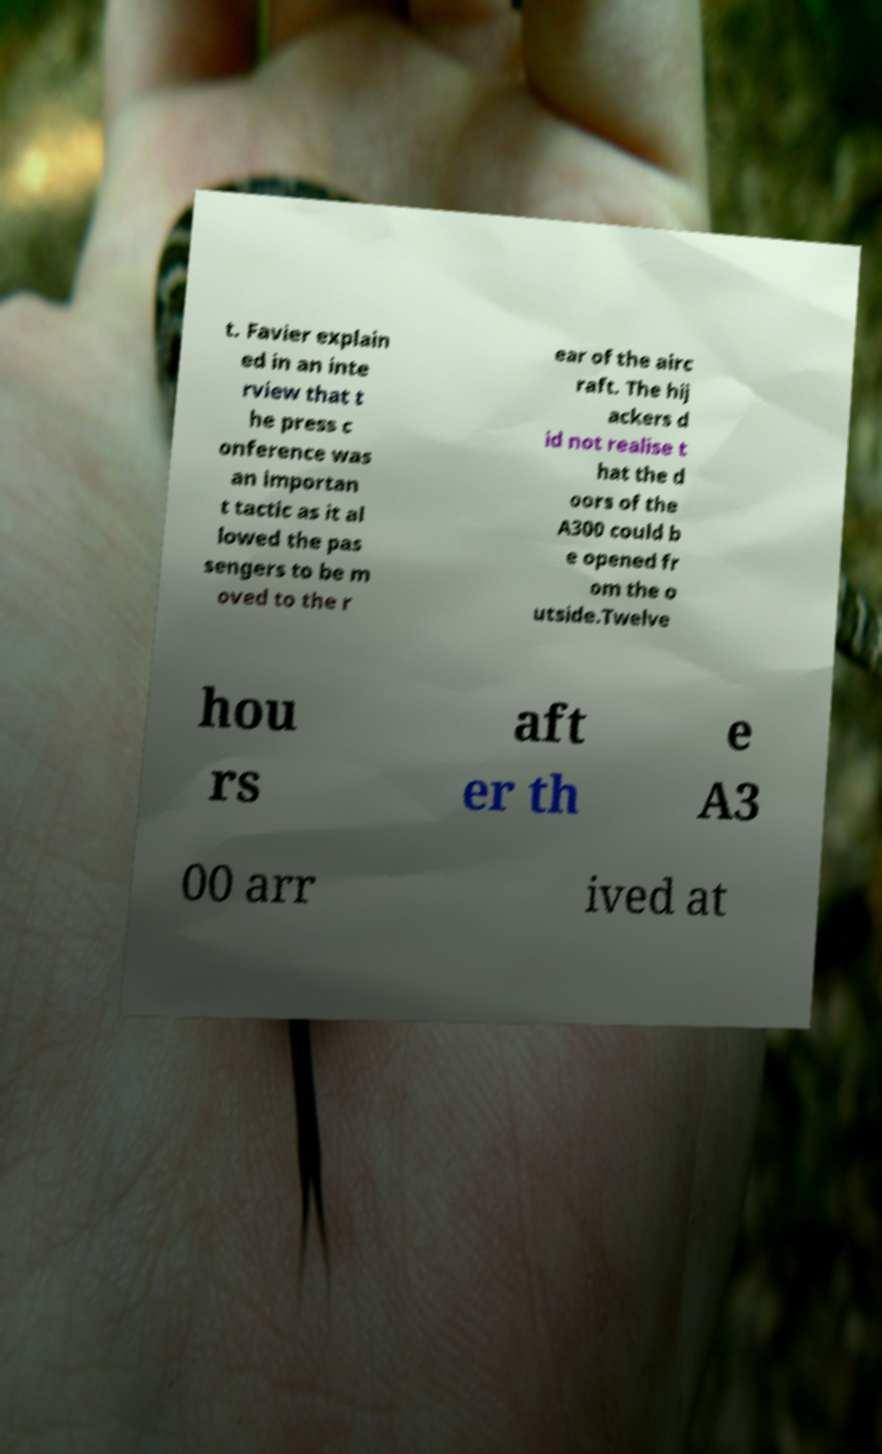There's text embedded in this image that I need extracted. Can you transcribe it verbatim? t. Favier explain ed in an inte rview that t he press c onference was an importan t tactic as it al lowed the pas sengers to be m oved to the r ear of the airc raft. The hij ackers d id not realise t hat the d oors of the A300 could b e opened fr om the o utside.Twelve hou rs aft er th e A3 00 arr ived at 